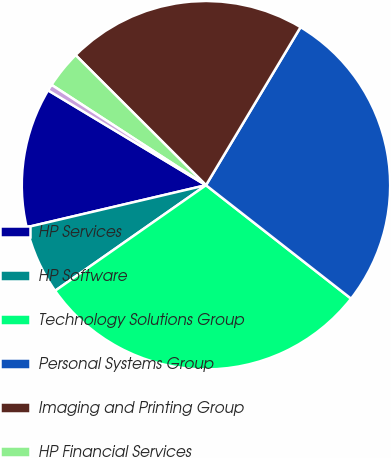Convert chart to OTSL. <chart><loc_0><loc_0><loc_500><loc_500><pie_chart><fcel>HP Services<fcel>HP Software<fcel>Technology Solutions Group<fcel>Personal Systems Group<fcel>Imaging and Printing Group<fcel>HP Financial Services<fcel>Corporate Investments<nl><fcel>12.28%<fcel>6.05%<fcel>29.72%<fcel>26.98%<fcel>21.1%<fcel>3.31%<fcel>0.56%<nl></chart> 